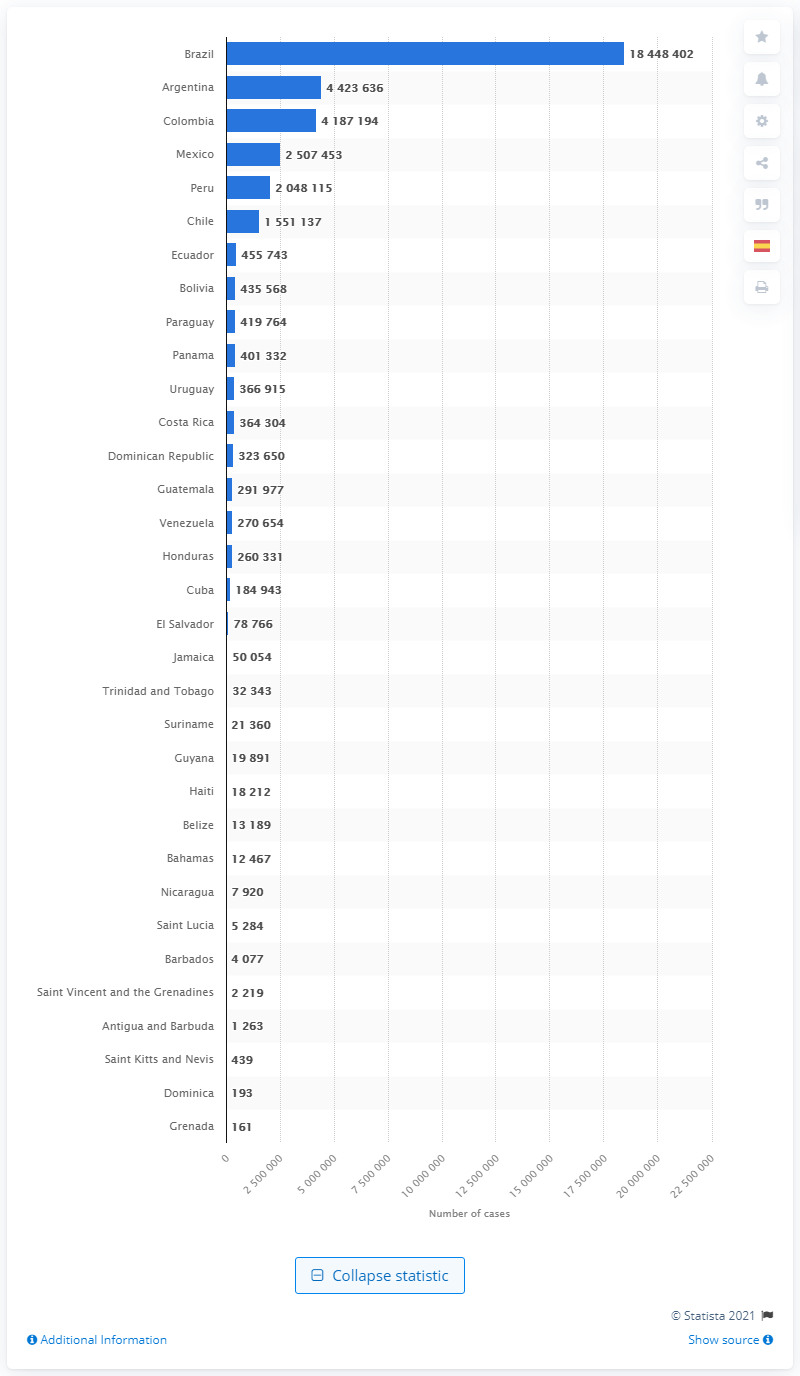Give some essential details in this illustration. As of June 2021, a total of 18,448,402 COVID-19 cases had been reported in Brazil. Argentina has the highest number of confirmed cases of COVID-19. Brazil has been significantly impacted by the COVID-19 pandemic. 